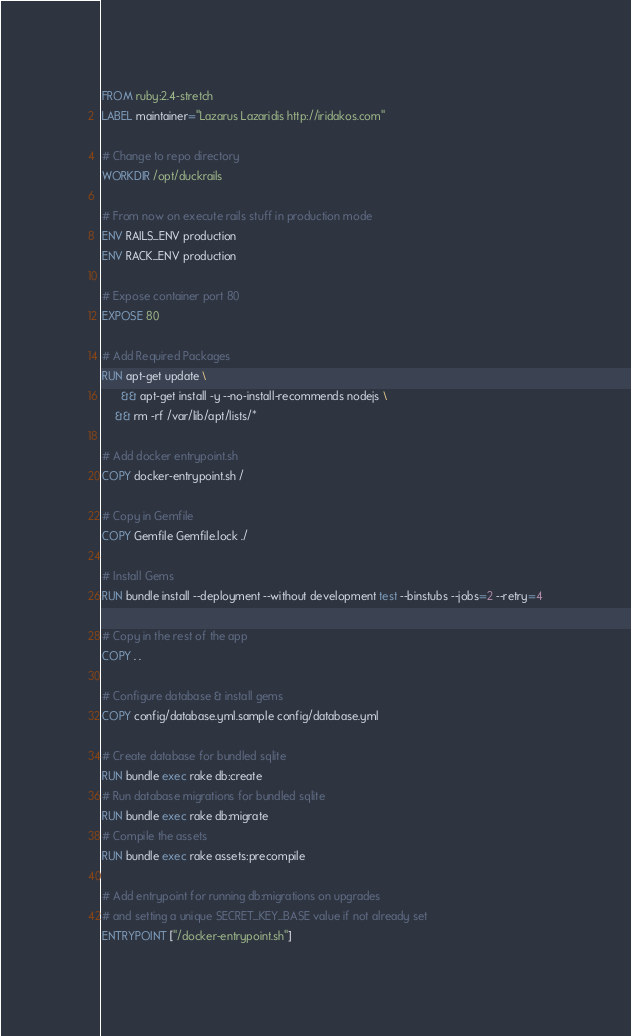<code> <loc_0><loc_0><loc_500><loc_500><_Dockerfile_>FROM ruby:2.4-stretch
LABEL maintainer="Lazarus Lazaridis http://iridakos.com"

# Change to repo directory
WORKDIR /opt/duckrails

# From now on execute rails stuff in production mode
ENV RAILS_ENV production
ENV RACK_ENV production

# Expose container port 80
EXPOSE 80

# Add Required Packages
RUN apt-get update \
	  && apt-get install -y --no-install-recommends nodejs \
    && rm -rf /var/lib/apt/lists/*

# Add docker entrypoint.sh
COPY docker-entrypoint.sh /

# Copy in Gemfile
COPY Gemfile Gemfile.lock ./

# Install Gems
RUN bundle install --deployment --without development test --binstubs --jobs=2 --retry=4

# Copy in the rest of the app
COPY . .

# Configure database & install gems
COPY config/database.yml.sample config/database.yml

# Create database for bundled sqlite
RUN bundle exec rake db:create
# Run database migrations for bundled sqlite
RUN bundle exec rake db:migrate
# Compile the assets
RUN bundle exec rake assets:precompile

# Add entrypoint for running db:migrations on upgrades
# and setting a unique SECRET_KEY_BASE value if not already set
ENTRYPOINT ["/docker-entrypoint.sh"]
</code> 